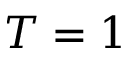<formula> <loc_0><loc_0><loc_500><loc_500>T = 1</formula> 